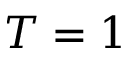<formula> <loc_0><loc_0><loc_500><loc_500>T = 1</formula> 